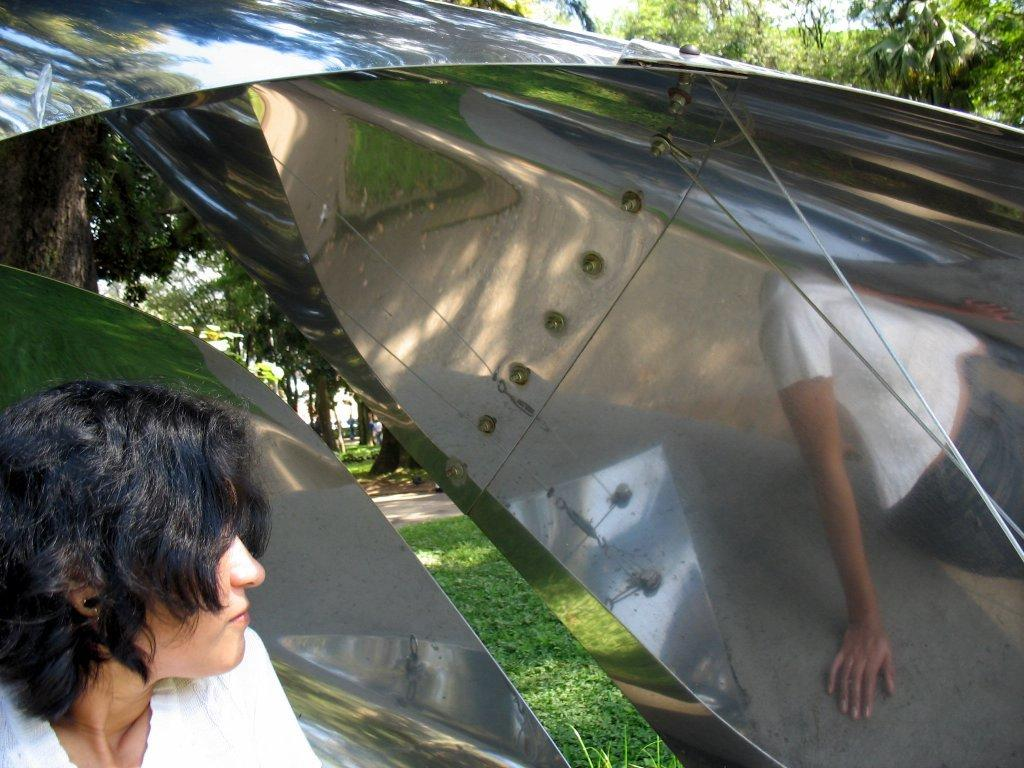Who or what is present in the image? There is a person in the image. What is located in the front of the image? There is a metal sheet in the front of the image. What type of vegetation can be seen at the bottom of the image? Grass is visible at the bottom of the image. What can be seen in the distance in the image? There are trees in the background of the image. What type of string is being used by the farmer in the image? There is no farmer or string present in the image. 